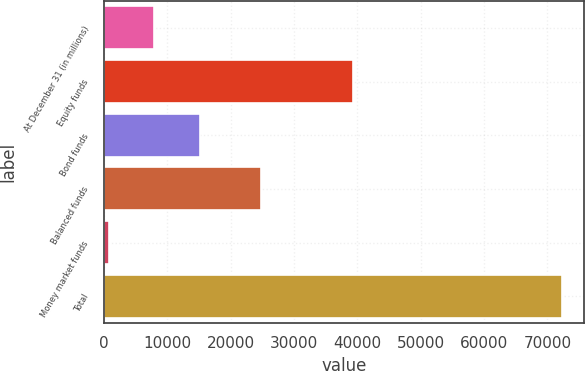Convert chart. <chart><loc_0><loc_0><loc_500><loc_500><bar_chart><fcel>At December 31 (in millions)<fcel>Equity funds<fcel>Bond funds<fcel>Balanced funds<fcel>Money market funds<fcel>Total<nl><fcel>7965.4<fcel>39284<fcel>15104.8<fcel>24849<fcel>826<fcel>72220<nl></chart> 